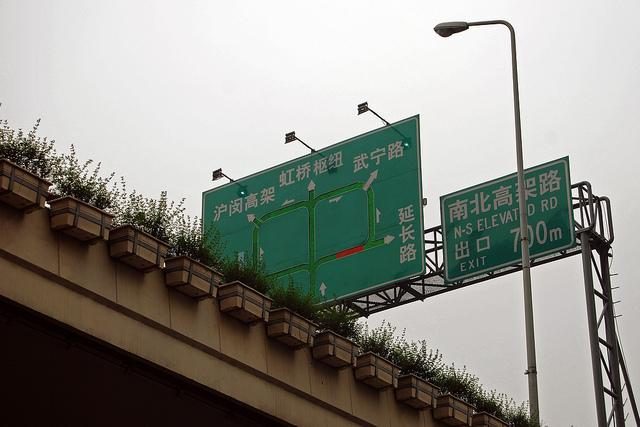According to the evidence up above where might you find the cameraman?

Choices:
A) china
B) south africa
C) america
D) india china 